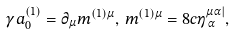<formula> <loc_0><loc_0><loc_500><loc_500>\gamma a _ { 0 } ^ { ( 1 ) } = \partial _ { \mu } m ^ { ( 1 ) \mu } , \, m ^ { ( 1 ) \mu } = 8 c \eta _ { \, \alpha } ^ { \mu \alpha | } ,</formula> 